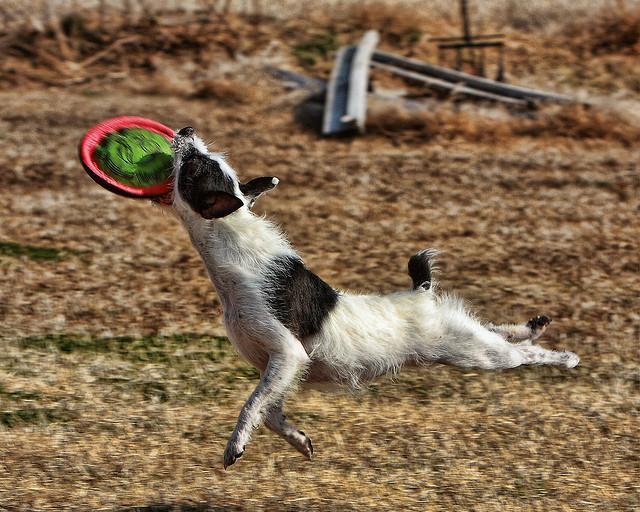How many of the dog's paws are touching the ground?
Give a very brief answer. 0. 